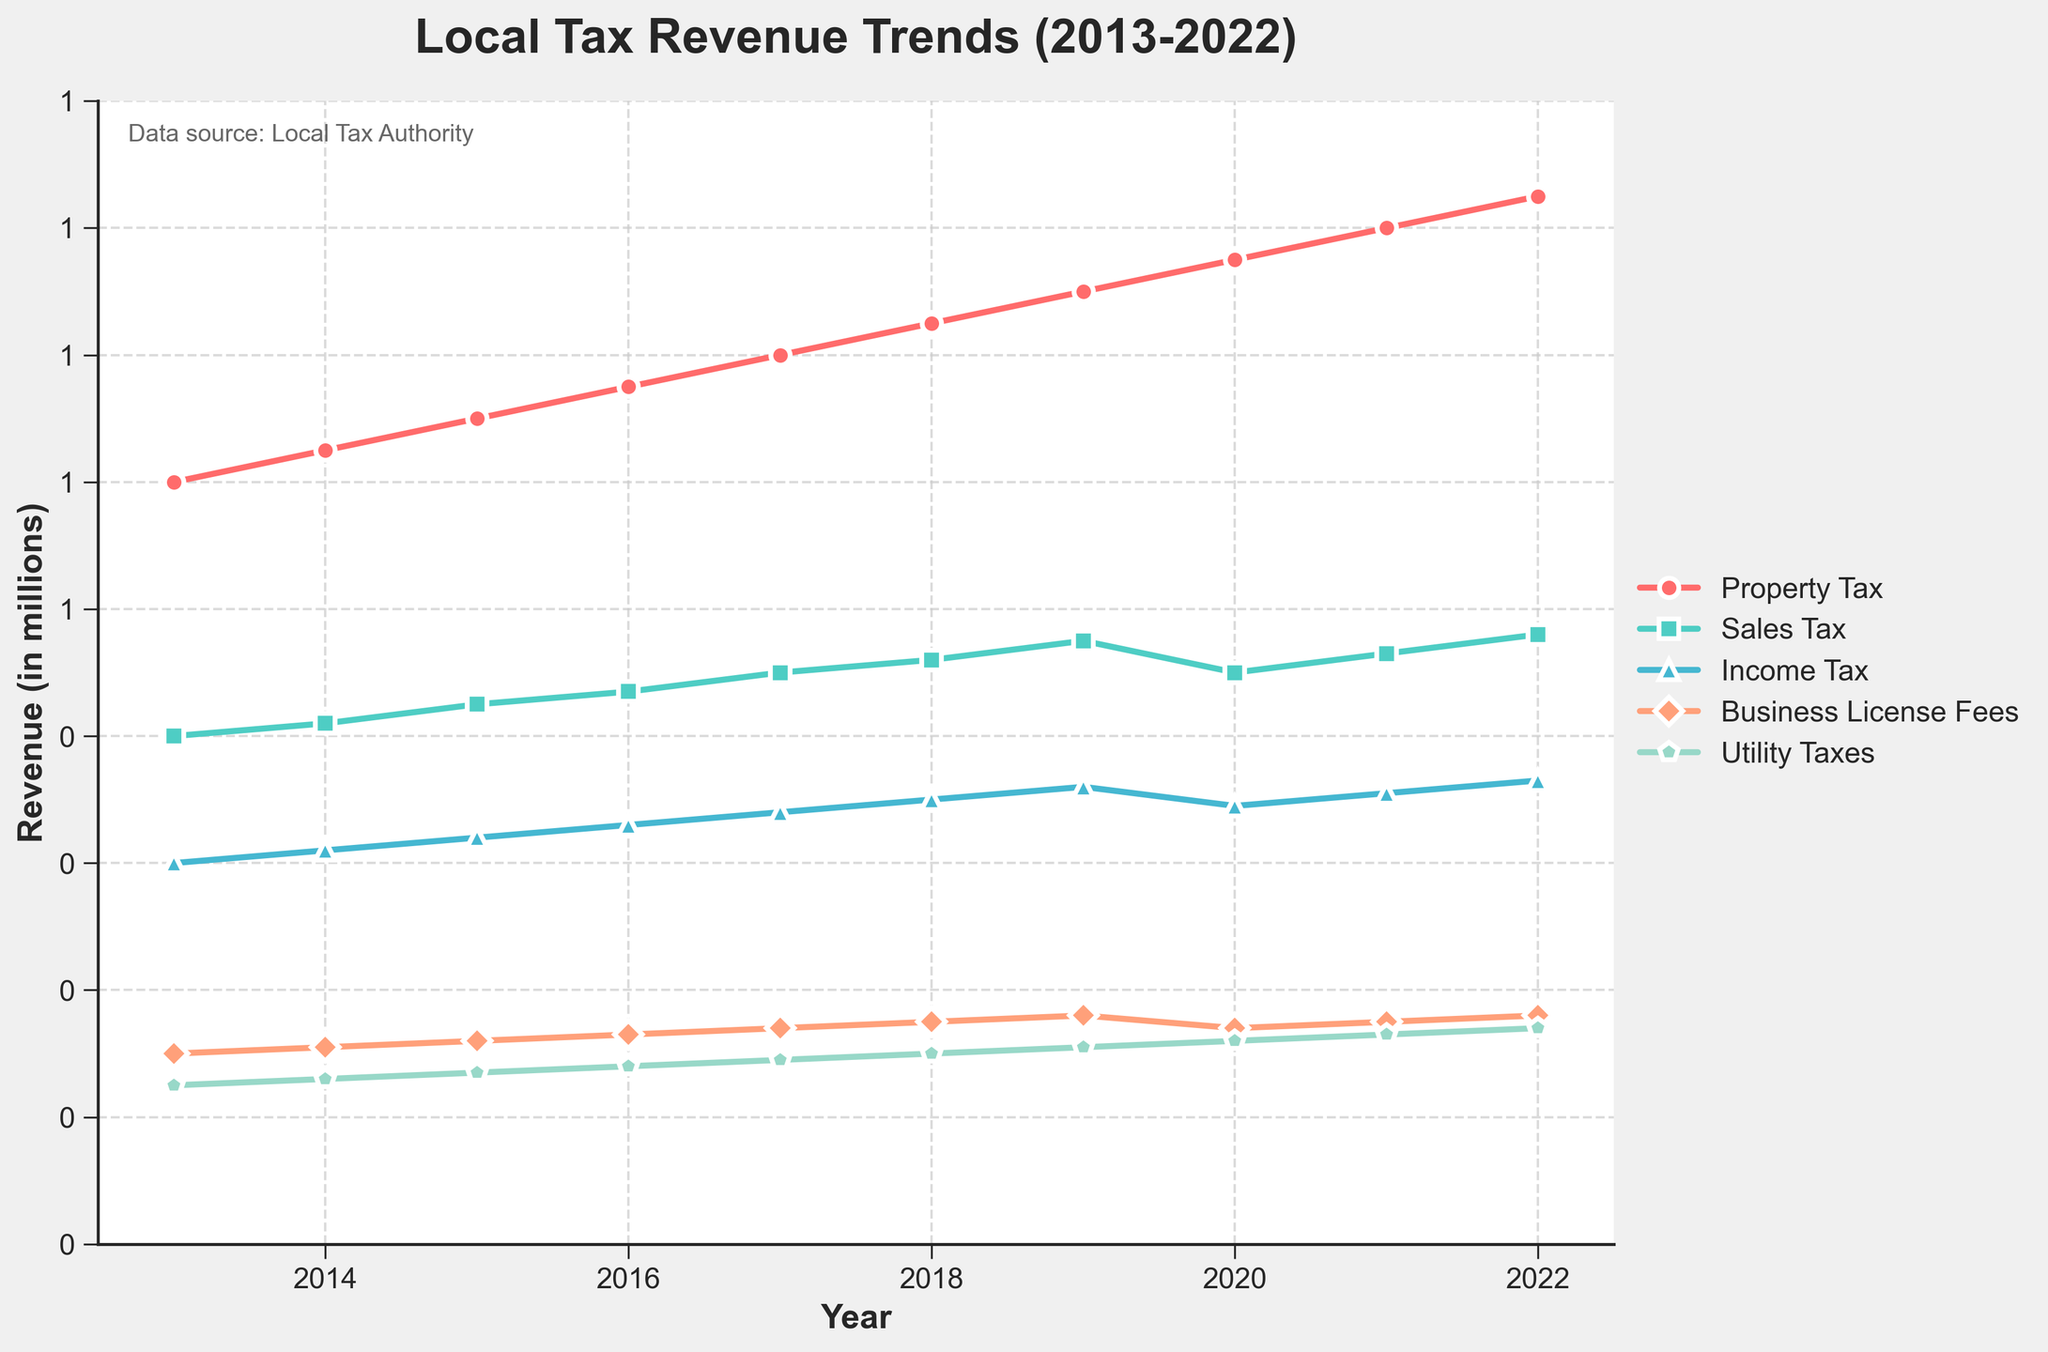How has the total local tax revenue changed from 2013 to 2022? To find the total local tax revenue for 2013, sum up all sources: (1200000 + 800000 + 600000 + 300000 + 250000) = 3150000. For 2022, do the same: (1650000 + 960000 + 730000 + 360000 + 340000) = 4040000. Then, calculate the difference: 4040000 - 3150000 = 890000.
Answer: Increased by 890000 Which source of local tax revenue showed the most consistent annual increase over the decade? By observing the lines in the figure, “Property Tax” shows the most consistent annual increase as there are no years with decreases or significant fluctuations.
Answer: Property Tax For which years did Sales Tax revenue decrease? Observing the trend lines in the figure, Sales Tax revenue decreased from 2019 (950000) to 2020 (900000).
Answer: 2020 What was the overall trend for Utility Taxes from 2013 to 2022? To determine the trend, observe the slope in the figure. Utility Taxes increased gradually almost every year: from 250000 in 2013 to 340000 in 2022.
Answer: Gradual increase How much more revenue did Property Tax generate in 2022 compared to Income Tax? For 2022, Property Tax revenue is 1650000 and Income Tax revenue is 730000. The difference is 1650000 - 730000 = 920000.
Answer: 920000 Which tax source experienced the largest drop in revenue over a single year and when did it happen? By analyzing the figure, Sales Tax experienced the largest drop between 2019 and 2020, falling from 950000 to 900000. The drop is 50000.
Answer: Sales Tax in 2020 What is the cumulative increase in Business License Fees from 2013 to 2022? Calculate the cumulative increase by subtracting the 2013 value (300000) from the 2022 value (360000): 360000 - 300000 = 60000.
Answer: 60000 Compare the highest revenue year for Property Tax with the lowest revenue year for Utility Taxes. What is the difference? The highest revenue year for Property Tax is 2022 with 1650000. The lowest revenue year for Utility Taxes is 2013 with 250000. The difference is 1650000 - 250000 = 1400000.
Answer: 1400000 How did the total tax revenue change after the year 2019? Sum the total tax revenue for 2019: (1500000 + 950000 + 720000 + 360000 + 310000) = 3840000. For 2020, sum again: (1550000 + 900000 + 690000 + 340000 + 320000) = 3800000. Calculate the difference: 3800000 - 3840000 = -40000. For subsequent years, add for 2021: 3920000 and for 2022: 4040000. Total tax revenue increases over these years.
Answer: Decreased in 2020, then increased Identify the year with the highest cumulative tax revenue and its value. Calculate the total for each year and find that 2022 has the highest with (1650000 + 960000 + 730000 + 360000 + 340000) = 4040000.
Answer: 2022, 4040000 